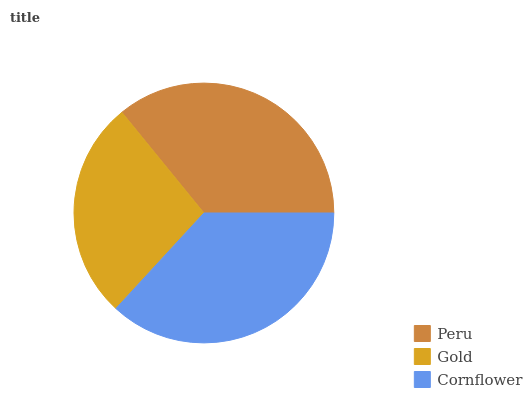Is Gold the minimum?
Answer yes or no. Yes. Is Cornflower the maximum?
Answer yes or no. Yes. Is Cornflower the minimum?
Answer yes or no. No. Is Gold the maximum?
Answer yes or no. No. Is Cornflower greater than Gold?
Answer yes or no. Yes. Is Gold less than Cornflower?
Answer yes or no. Yes. Is Gold greater than Cornflower?
Answer yes or no. No. Is Cornflower less than Gold?
Answer yes or no. No. Is Peru the high median?
Answer yes or no. Yes. Is Peru the low median?
Answer yes or no. Yes. Is Cornflower the high median?
Answer yes or no. No. Is Cornflower the low median?
Answer yes or no. No. 